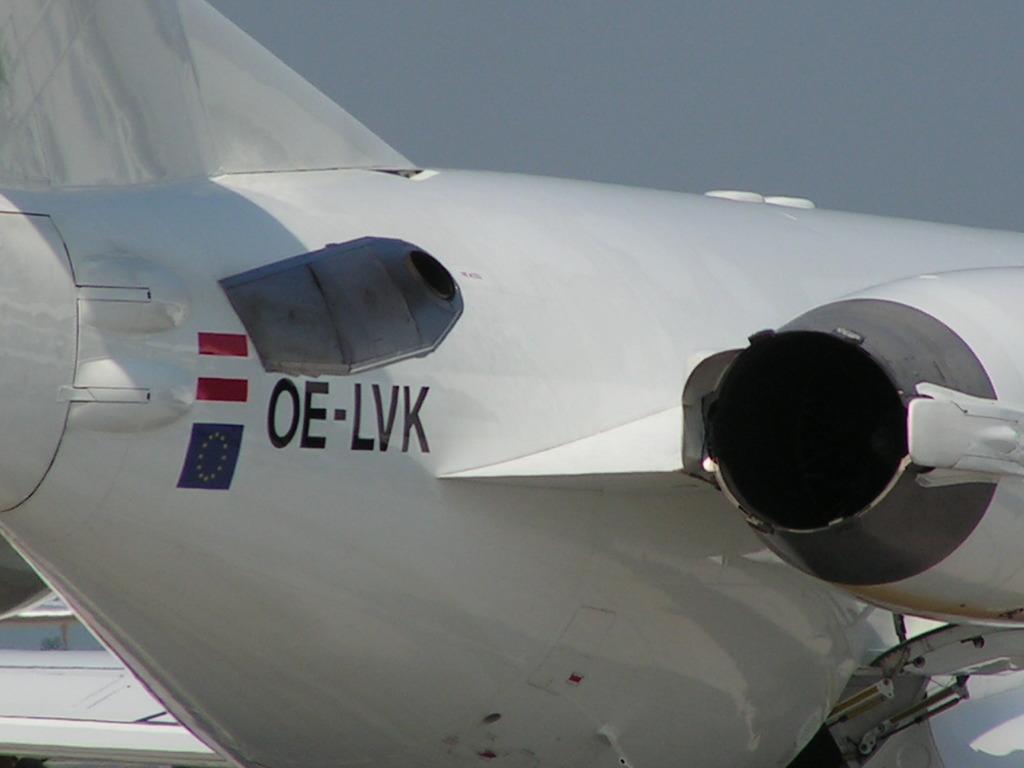What letters are on the plane?
Keep it short and to the point. Oe-lvk. 